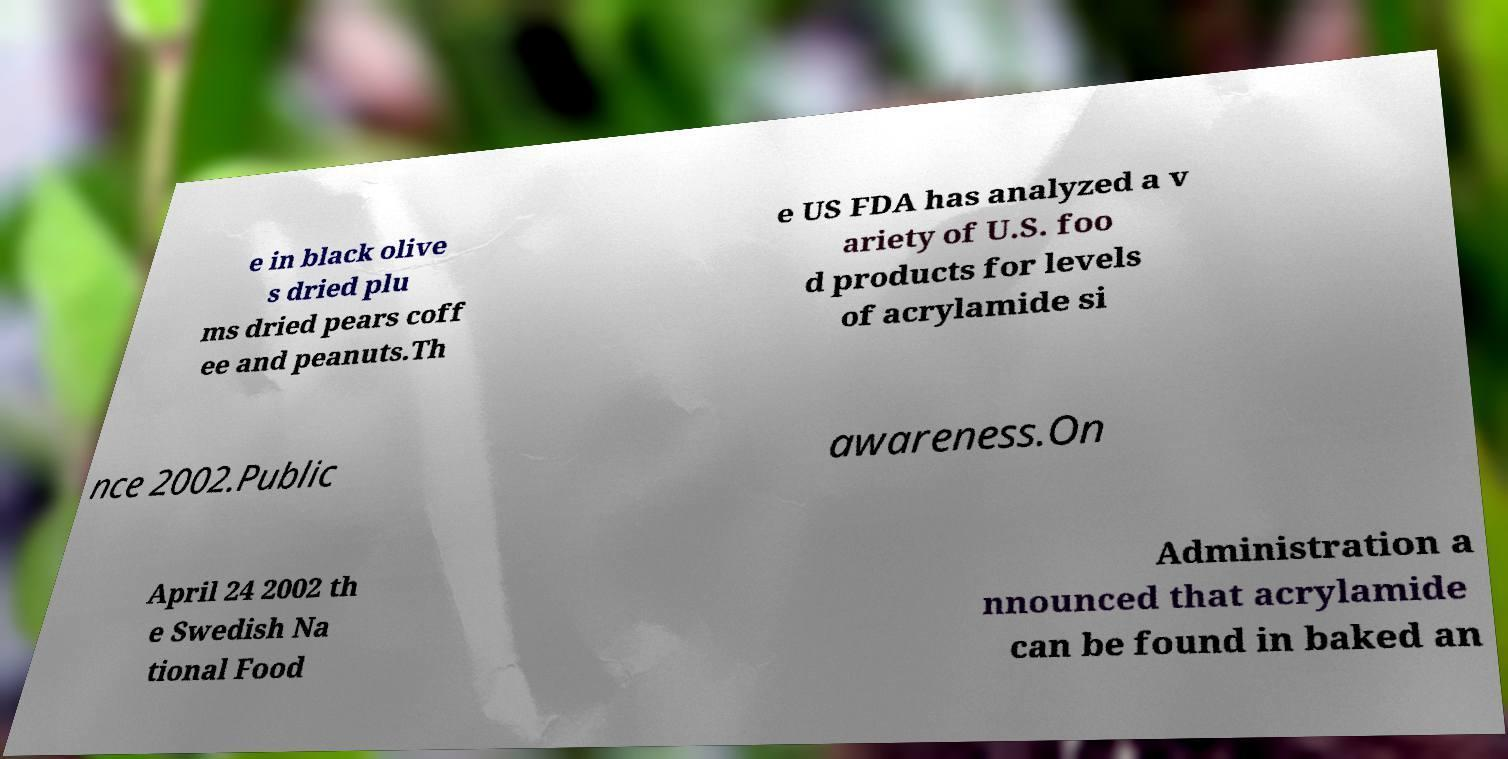Can you accurately transcribe the text from the provided image for me? e in black olive s dried plu ms dried pears coff ee and peanuts.Th e US FDA has analyzed a v ariety of U.S. foo d products for levels of acrylamide si nce 2002.Public awareness.On April 24 2002 th e Swedish Na tional Food Administration a nnounced that acrylamide can be found in baked an 